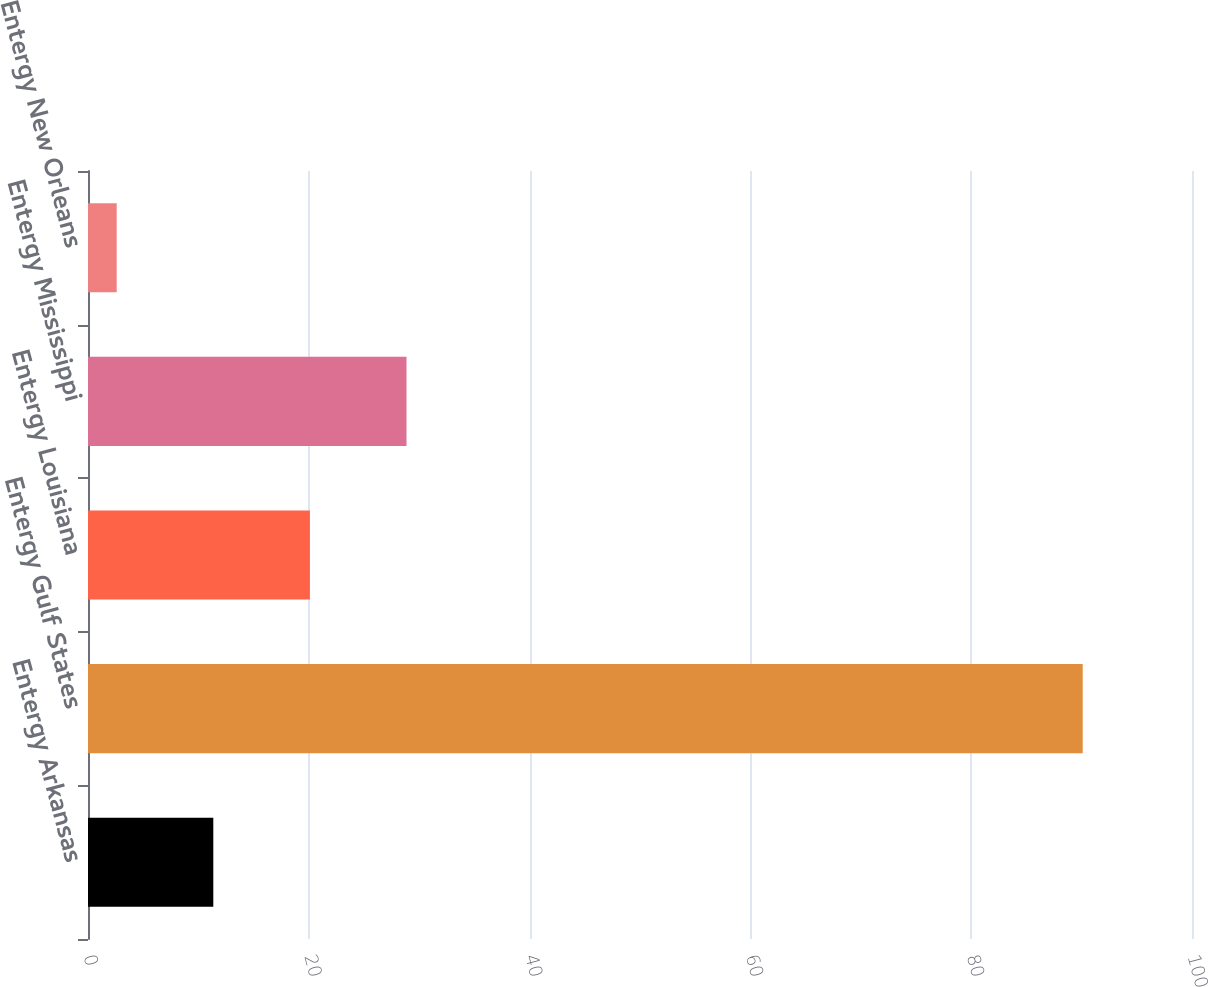Convert chart. <chart><loc_0><loc_0><loc_500><loc_500><bar_chart><fcel>Entergy Arkansas<fcel>Entergy Gulf States<fcel>Entergy Louisiana<fcel>Entergy Mississippi<fcel>Entergy New Orleans<nl><fcel>11.35<fcel>90.1<fcel>20.1<fcel>28.85<fcel>2.6<nl></chart> 